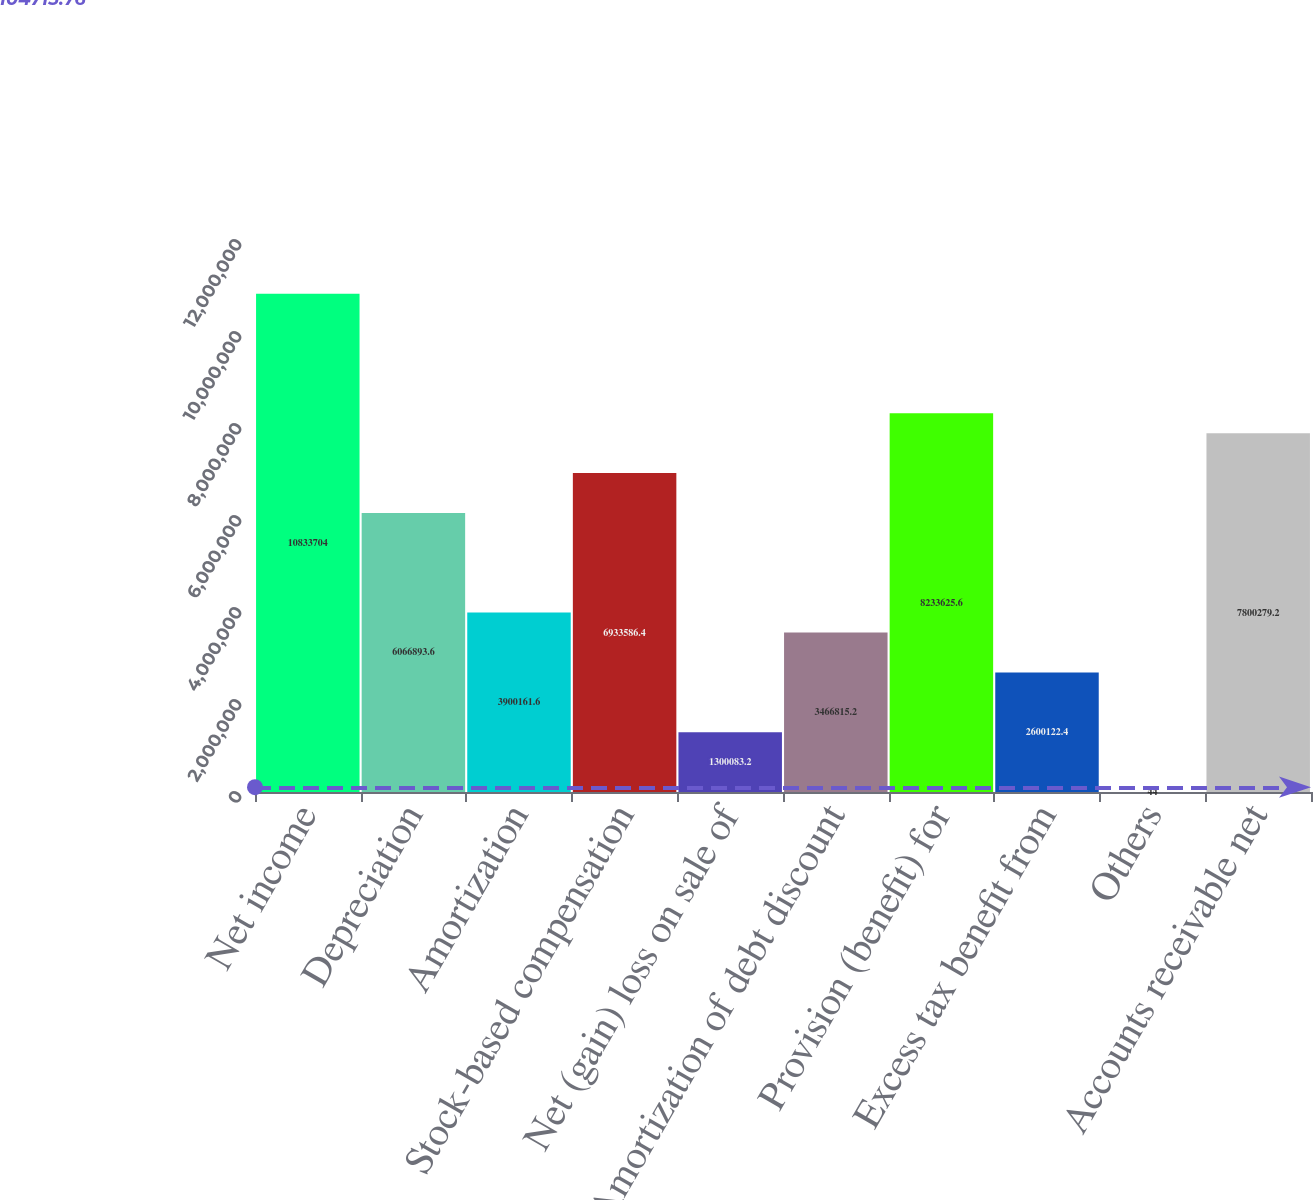Convert chart. <chart><loc_0><loc_0><loc_500><loc_500><bar_chart><fcel>Net income<fcel>Depreciation<fcel>Amortization<fcel>Stock-based compensation<fcel>Net (gain) loss on sale of<fcel>Amortization of debt discount<fcel>Provision (benefit) for<fcel>Excess tax benefit from<fcel>Others<fcel>Accounts receivable net<nl><fcel>1.08337e+07<fcel>6.06689e+06<fcel>3.90016e+06<fcel>6.93359e+06<fcel>1.30008e+06<fcel>3.46682e+06<fcel>8.23363e+06<fcel>2.60012e+06<fcel>44<fcel>7.80028e+06<nl></chart> 